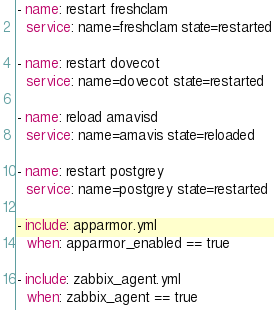Convert code to text. <code><loc_0><loc_0><loc_500><loc_500><_YAML_>
- name: restart freshclam
  service: name=freshclam state=restarted

- name: restart dovecot
  service: name=dovecot state=restarted

- name: reload amavisd
  service: name=amavis state=reloaded

- name: restart postgrey
  service: name=postgrey state=restarted

- include: apparmor.yml
  when: apparmor_enabled == true

- include: zabbix_agent.yml
  when: zabbix_agent == true
</code> 